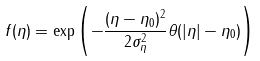Convert formula to latex. <formula><loc_0><loc_0><loc_500><loc_500>f ( \eta ) = \exp \left ( - \frac { ( \eta - \eta _ { 0 } ) ^ { 2 } } { 2 \sigma _ { \eta } ^ { 2 } } \theta ( | \eta | - \eta _ { 0 } ) \right )</formula> 